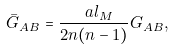Convert formula to latex. <formula><loc_0><loc_0><loc_500><loc_500>\bar { G } _ { A B } = \frac { \ a l _ { M } } { 2 n ( n - 1 ) } G _ { A B } ,</formula> 